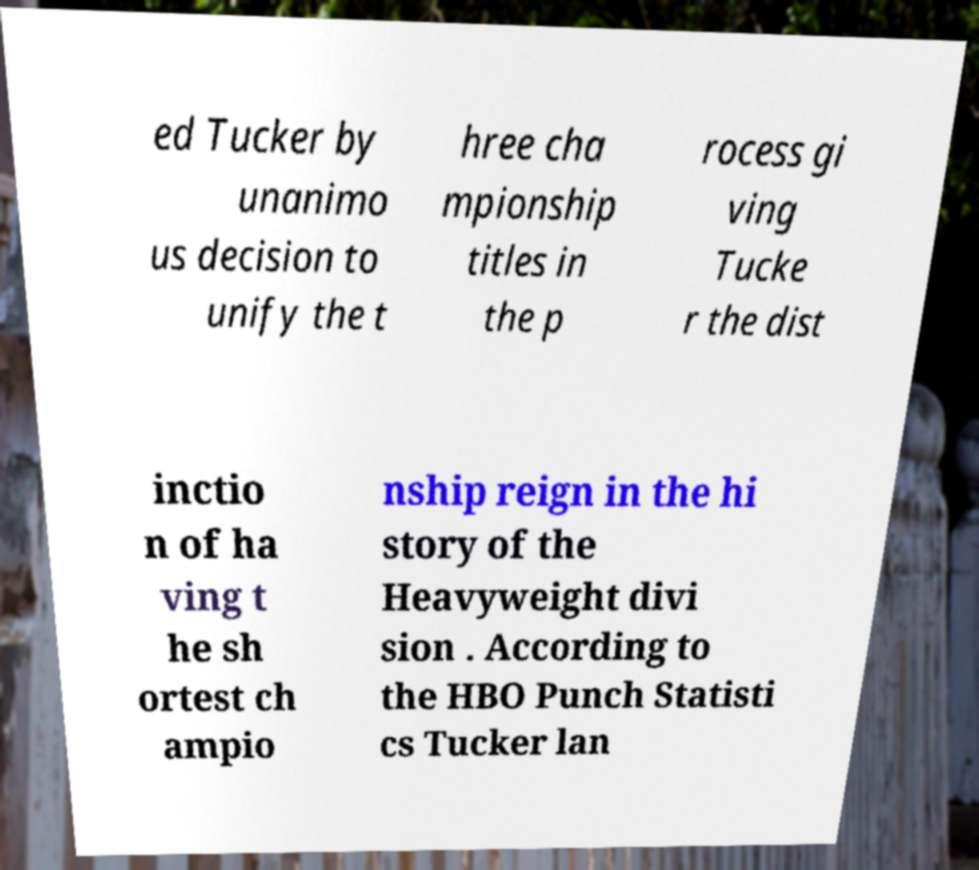For documentation purposes, I need the text within this image transcribed. Could you provide that? ed Tucker by unanimo us decision to unify the t hree cha mpionship titles in the p rocess gi ving Tucke r the dist inctio n of ha ving t he sh ortest ch ampio nship reign in the hi story of the Heavyweight divi sion . According to the HBO Punch Statisti cs Tucker lan 